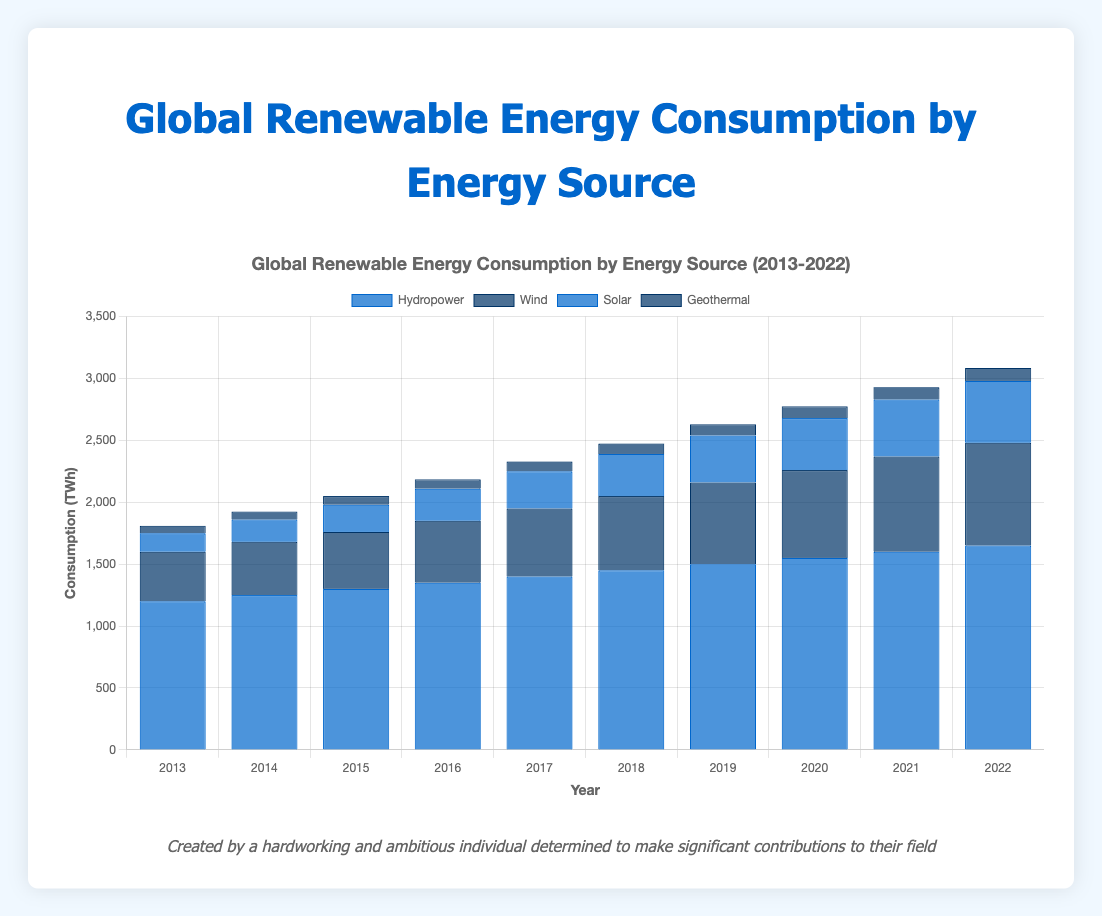What is the total consumption TWh of all energy sources in 2022? To find the total consumption in 2022, sum up the consumption of all energy sources for that year: Hydropower (1650 TWh) + Wind (830 TWh) + Solar (500 TWh) + Geothermal (105 TWh) = 3085 TWh
Answer: 3085 TWh How did solar energy consumption change from 2013 to 2022? Compare the consumption values for solar energy in 2013 and 2022. In 2013, the consumption was 150 TWh, and in 2022, it was 500 TWh. The change is 500 - 150 = 350 TWh increase.
Answer: Increased by 350 TWh What is the average consumption of geothermic energy over the past decade? Sum the consumption values of geothermic energy from 2013 to 2022 and divide by the number of years (10): 
(60 + 65 + 70 + 75 + 80 + 85 + 90 + 95 + 100 + 105) = 825 TWh 
825 / 10 = 82.5 TWh
Answer: 82.5 TWh Which energy source consistently showed an increase every year from 2013 to 2022? Check the consumption trend for each energy source year by year. Hydropower, Wind, Solar, and Geothermal each show consistent increases every year.
Answer: All sources show an increase What was the total increase in wind energy consumption from 2014 to 2018? Calculate the total increase by finding the difference between 2018 and 2014 values:
- 2014: 430 TWh
- 2018: 600 TWh
Total increase: 600 - 430 = 170 TWh
Answer: 170 TWh 